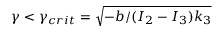<formula> <loc_0><loc_0><loc_500><loc_500>\gamma < \gamma _ { c r i t } = \sqrt { - b / ( I _ { 2 } - I _ { 3 } ) k _ { 3 } }</formula> 